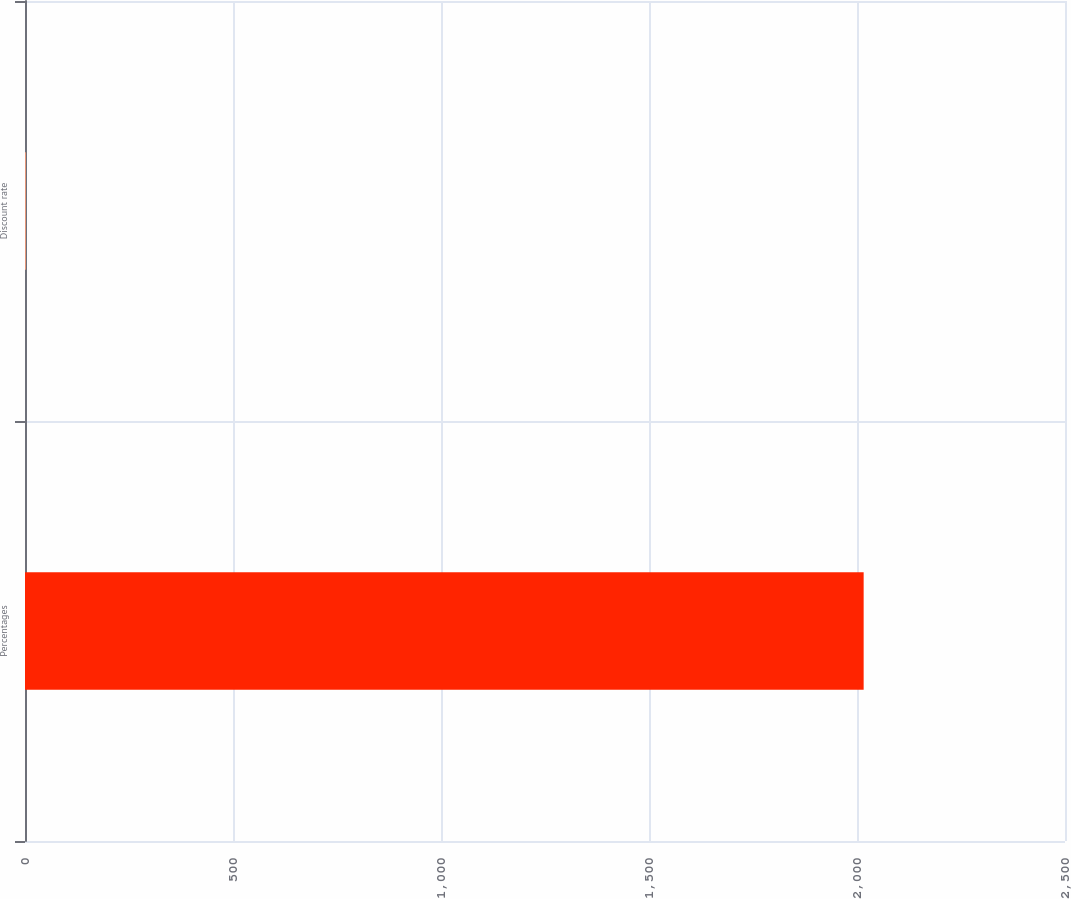<chart> <loc_0><loc_0><loc_500><loc_500><bar_chart><fcel>Percentages<fcel>Discount rate<nl><fcel>2016<fcel>2<nl></chart> 